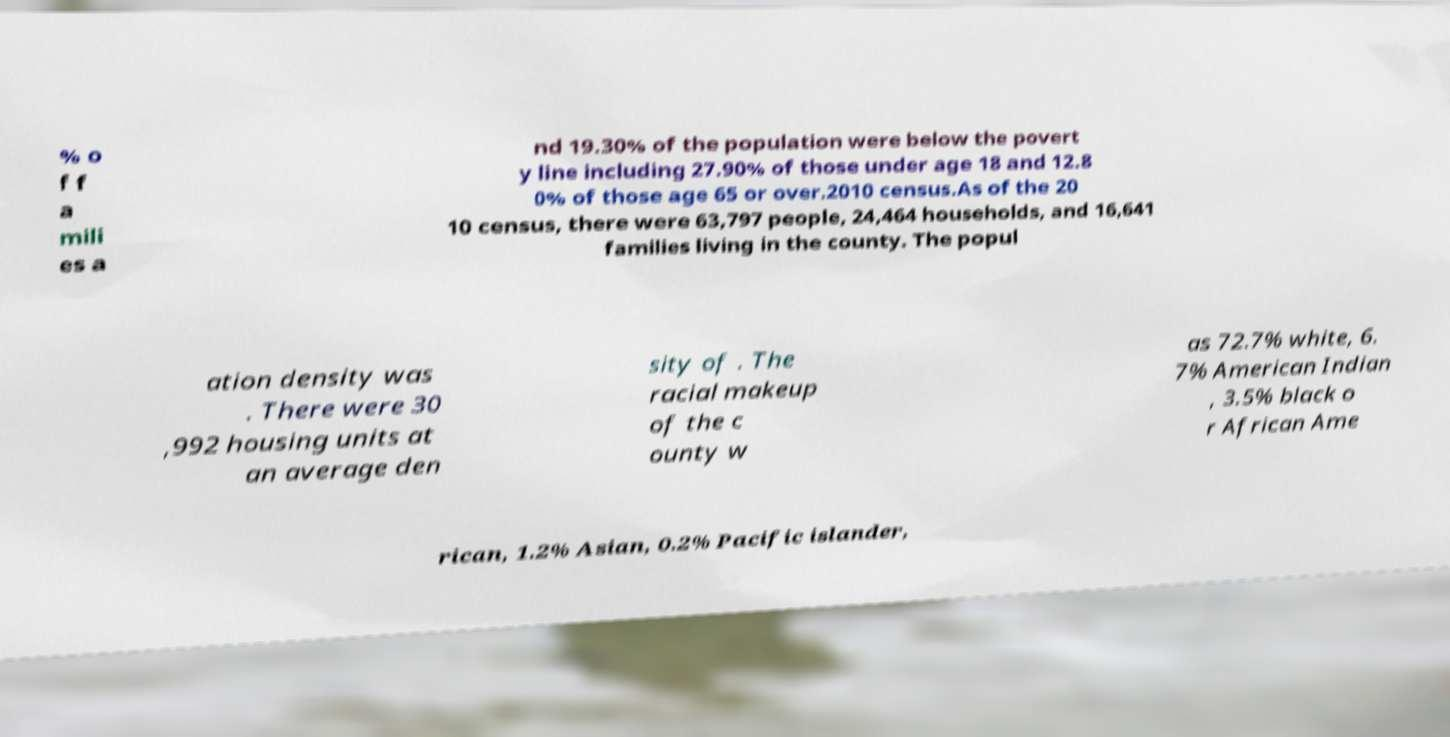Can you read and provide the text displayed in the image?This photo seems to have some interesting text. Can you extract and type it out for me? % o f f a mili es a nd 19.30% of the population were below the povert y line including 27.90% of those under age 18 and 12.8 0% of those age 65 or over.2010 census.As of the 20 10 census, there were 63,797 people, 24,464 households, and 16,641 families living in the county. The popul ation density was . There were 30 ,992 housing units at an average den sity of . The racial makeup of the c ounty w as 72.7% white, 6. 7% American Indian , 3.5% black o r African Ame rican, 1.2% Asian, 0.2% Pacific islander, 